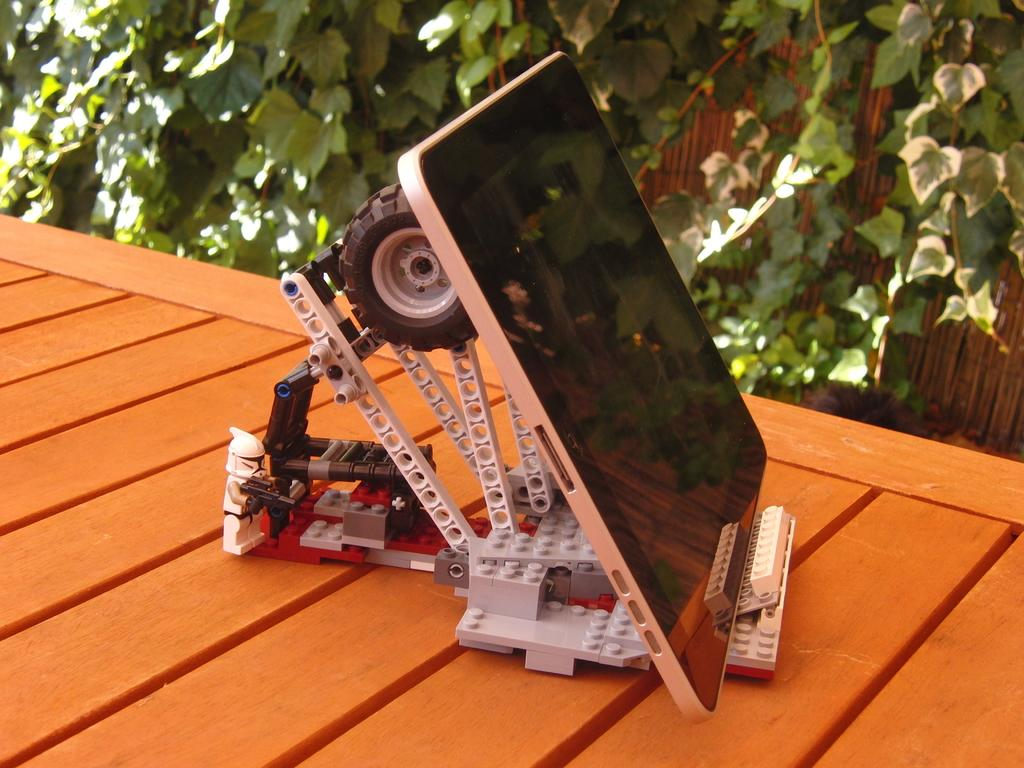What is the main subject in the center of the image? There is a tab in the center of the image. What is the tab attached to? The tab is on a wooden rack. What type of vegetation can be seen at the top side of the image? There are trees at the top side of the image. How many balls are being used to stop the wooden rack in the image? There are no balls present in the image, and the wooden rack is not being stopped by any balls. 